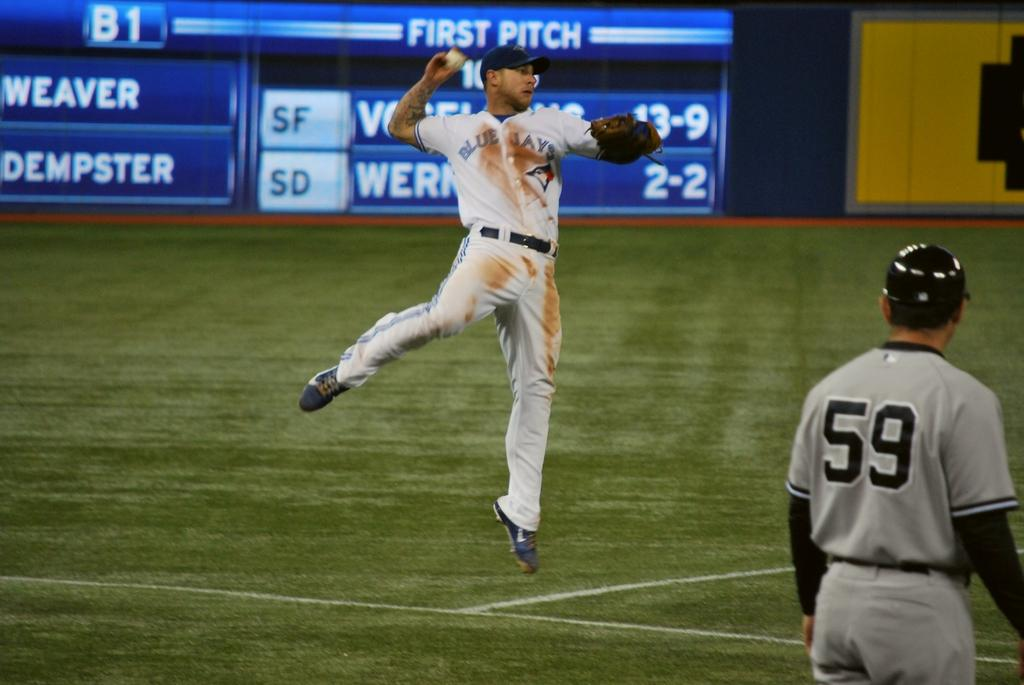<image>
Share a concise interpretation of the image provided. The scoreboard behind two baseball players indicates that this is the first pitch. 